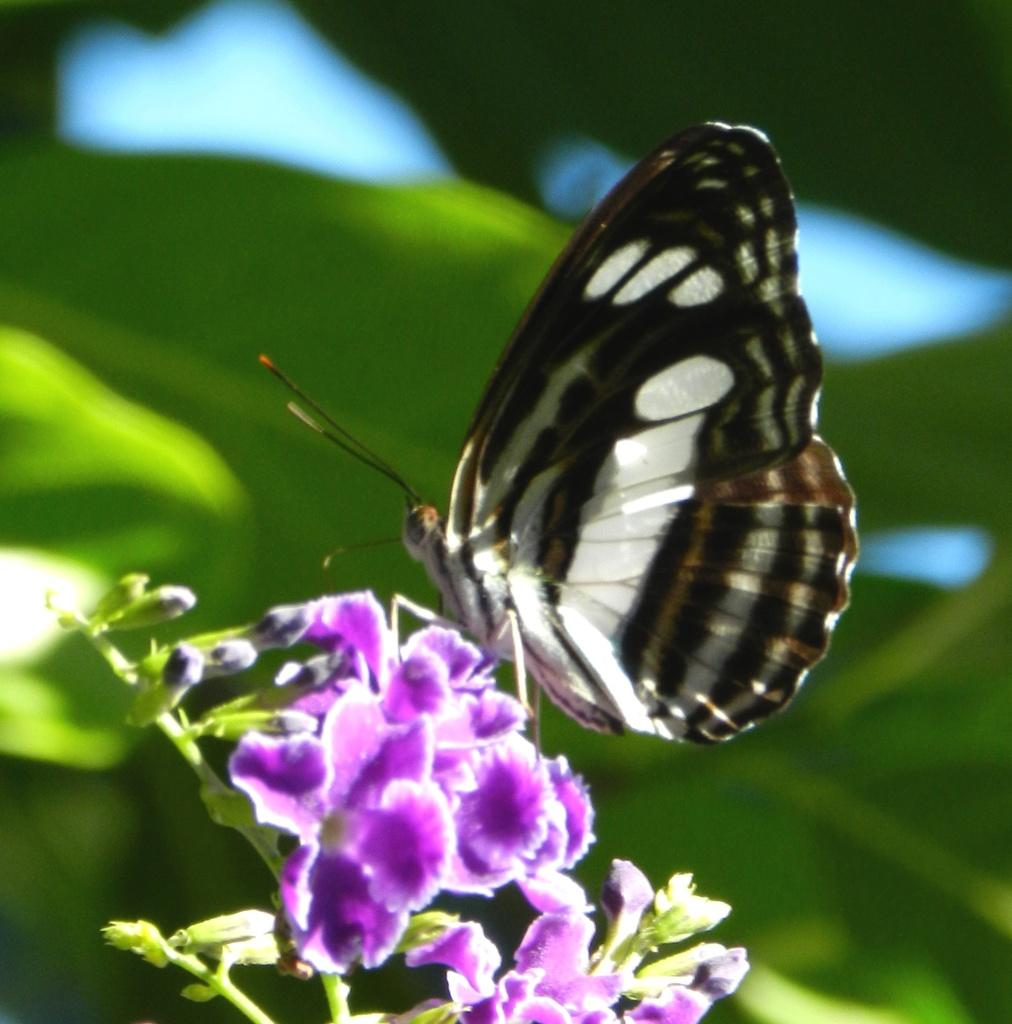What is the main subject of the image? There is a butterfly in the image. What is the butterfly sitting on? The butterfly is on violet color flowers. What color is the background of the image? The background of the image is green. How is the background of the image depicted? The background is blurred. What type of hook can be seen hanging from the violet flowers in the image? There is no hook present in the image; it features a butterfly on violet flowers with a blurred green background. 